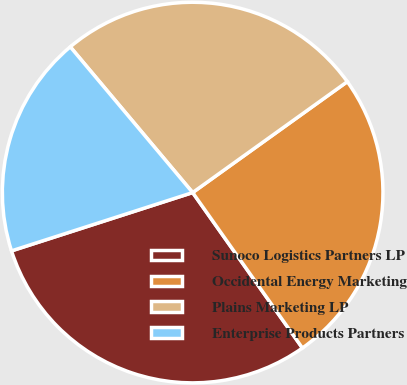Convert chart to OTSL. <chart><loc_0><loc_0><loc_500><loc_500><pie_chart><fcel>Sunoco Logistics Partners LP<fcel>Occidental Energy Marketing<fcel>Plains Marketing LP<fcel>Enterprise Products Partners<nl><fcel>29.83%<fcel>25.12%<fcel>26.22%<fcel>18.84%<nl></chart> 